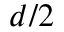Convert formula to latex. <formula><loc_0><loc_0><loc_500><loc_500>d / 2</formula> 